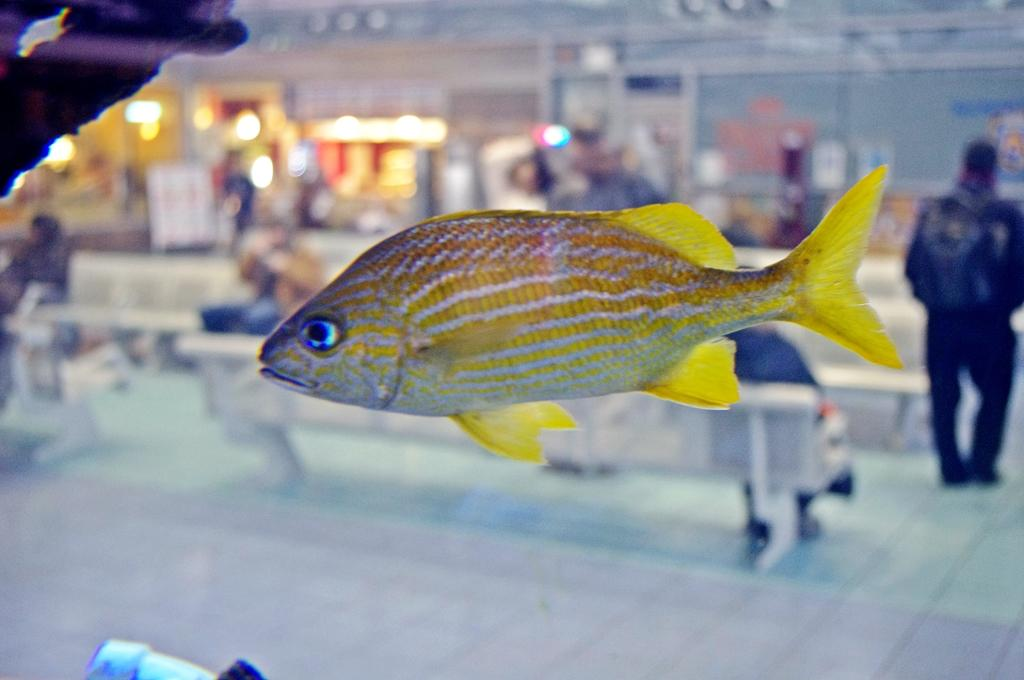What type of animal can be seen in the image? There is a yellow fish in the image. What are the people in the image doing? Some people are sitting in groups, while others are standing. How is the background behind the people depicted in the image? The background behind the people is blurred. Where is the harbor located in the image? There is no harbor present in the image. What type of animal is washing the people in the image? There is no animal present in the image, and no one is being washed. 